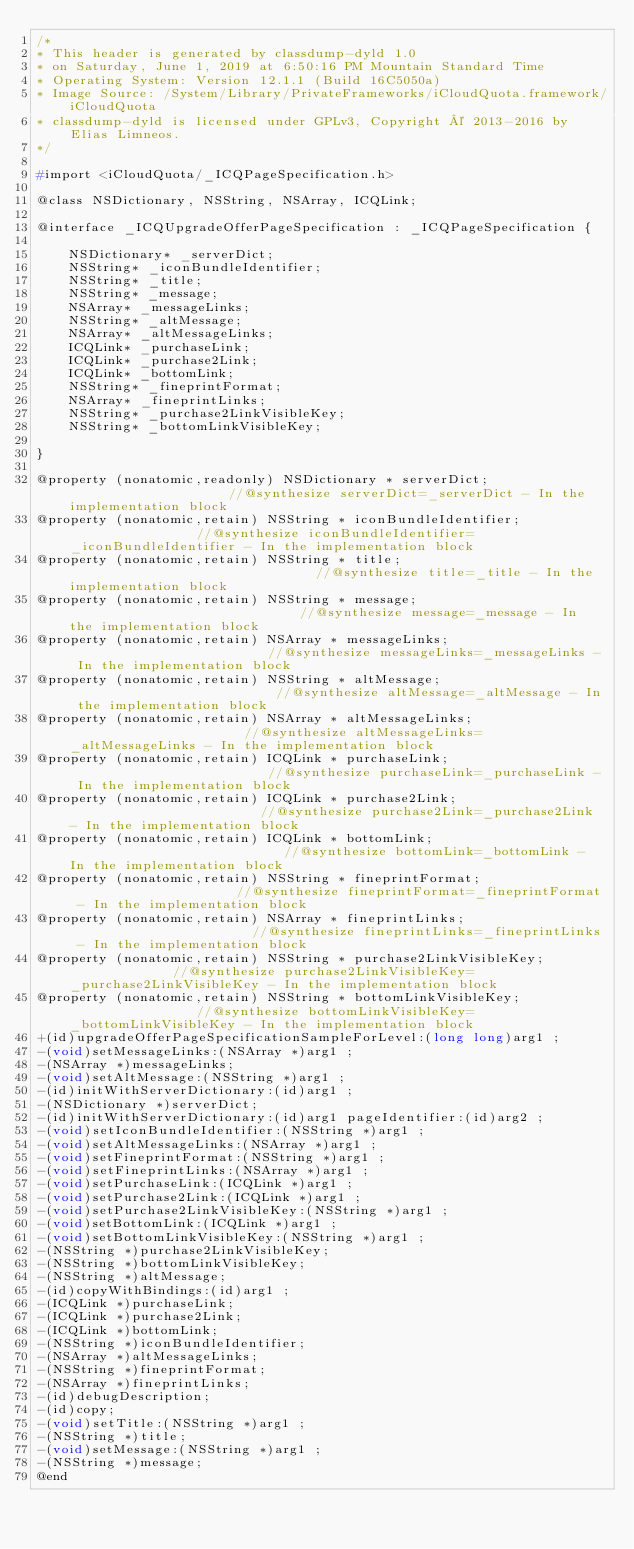Convert code to text. <code><loc_0><loc_0><loc_500><loc_500><_C_>/*
* This header is generated by classdump-dyld 1.0
* on Saturday, June 1, 2019 at 6:50:16 PM Mountain Standard Time
* Operating System: Version 12.1.1 (Build 16C5050a)
* Image Source: /System/Library/PrivateFrameworks/iCloudQuota.framework/iCloudQuota
* classdump-dyld is licensed under GPLv3, Copyright © 2013-2016 by Elias Limneos.
*/

#import <iCloudQuota/_ICQPageSpecification.h>

@class NSDictionary, NSString, NSArray, ICQLink;

@interface _ICQUpgradeOfferPageSpecification : _ICQPageSpecification {

	NSDictionary* _serverDict;
	NSString* _iconBundleIdentifier;
	NSString* _title;
	NSString* _message;
	NSArray* _messageLinks;
	NSString* _altMessage;
	NSArray* _altMessageLinks;
	ICQLink* _purchaseLink;
	ICQLink* _purchase2Link;
	ICQLink* _bottomLink;
	NSString* _fineprintFormat;
	NSArray* _fineprintLinks;
	NSString* _purchase2LinkVisibleKey;
	NSString* _bottomLinkVisibleKey;

}

@property (nonatomic,readonly) NSDictionary * serverDict;                     //@synthesize serverDict=_serverDict - In the implementation block
@property (nonatomic,retain) NSString * iconBundleIdentifier;                 //@synthesize iconBundleIdentifier=_iconBundleIdentifier - In the implementation block
@property (nonatomic,retain) NSString * title;                                //@synthesize title=_title - In the implementation block
@property (nonatomic,retain) NSString * message;                              //@synthesize message=_message - In the implementation block
@property (nonatomic,retain) NSArray * messageLinks;                          //@synthesize messageLinks=_messageLinks - In the implementation block
@property (nonatomic,retain) NSString * altMessage;                           //@synthesize altMessage=_altMessage - In the implementation block
@property (nonatomic,retain) NSArray * altMessageLinks;                       //@synthesize altMessageLinks=_altMessageLinks - In the implementation block
@property (nonatomic,retain) ICQLink * purchaseLink;                          //@synthesize purchaseLink=_purchaseLink - In the implementation block
@property (nonatomic,retain) ICQLink * purchase2Link;                         //@synthesize purchase2Link=_purchase2Link - In the implementation block
@property (nonatomic,retain) ICQLink * bottomLink;                            //@synthesize bottomLink=_bottomLink - In the implementation block
@property (nonatomic,retain) NSString * fineprintFormat;                      //@synthesize fineprintFormat=_fineprintFormat - In the implementation block
@property (nonatomic,retain) NSArray * fineprintLinks;                        //@synthesize fineprintLinks=_fineprintLinks - In the implementation block
@property (nonatomic,retain) NSString * purchase2LinkVisibleKey;              //@synthesize purchase2LinkVisibleKey=_purchase2LinkVisibleKey - In the implementation block
@property (nonatomic,retain) NSString * bottomLinkVisibleKey;                 //@synthesize bottomLinkVisibleKey=_bottomLinkVisibleKey - In the implementation block
+(id)upgradeOfferPageSpecificationSampleForLevel:(long long)arg1 ;
-(void)setMessageLinks:(NSArray *)arg1 ;
-(NSArray *)messageLinks;
-(void)setAltMessage:(NSString *)arg1 ;
-(id)initWithServerDictionary:(id)arg1 ;
-(NSDictionary *)serverDict;
-(id)initWithServerDictionary:(id)arg1 pageIdentifier:(id)arg2 ;
-(void)setIconBundleIdentifier:(NSString *)arg1 ;
-(void)setAltMessageLinks:(NSArray *)arg1 ;
-(void)setFineprintFormat:(NSString *)arg1 ;
-(void)setFineprintLinks:(NSArray *)arg1 ;
-(void)setPurchaseLink:(ICQLink *)arg1 ;
-(void)setPurchase2Link:(ICQLink *)arg1 ;
-(void)setPurchase2LinkVisibleKey:(NSString *)arg1 ;
-(void)setBottomLink:(ICQLink *)arg1 ;
-(void)setBottomLinkVisibleKey:(NSString *)arg1 ;
-(NSString *)purchase2LinkVisibleKey;
-(NSString *)bottomLinkVisibleKey;
-(NSString *)altMessage;
-(id)copyWithBindings:(id)arg1 ;
-(ICQLink *)purchaseLink;
-(ICQLink *)purchase2Link;
-(ICQLink *)bottomLink;
-(NSString *)iconBundleIdentifier;
-(NSArray *)altMessageLinks;
-(NSString *)fineprintFormat;
-(NSArray *)fineprintLinks;
-(id)debugDescription;
-(id)copy;
-(void)setTitle:(NSString *)arg1 ;
-(NSString *)title;
-(void)setMessage:(NSString *)arg1 ;
-(NSString *)message;
@end

</code> 